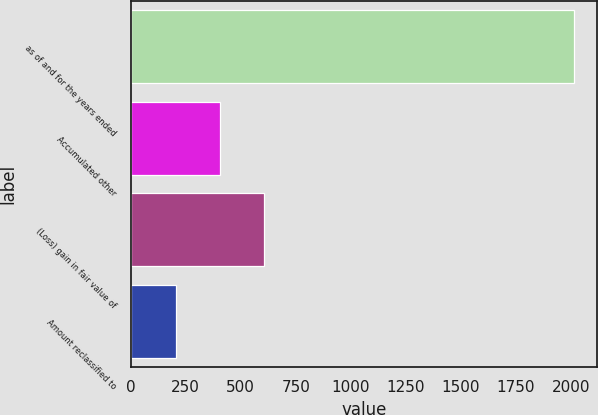<chart> <loc_0><loc_0><loc_500><loc_500><bar_chart><fcel>as of and for the years ended<fcel>Accumulated other<fcel>(Loss) gain in fair value of<fcel>Amount reclassified to<nl><fcel>2017<fcel>405.8<fcel>607.2<fcel>204.4<nl></chart> 